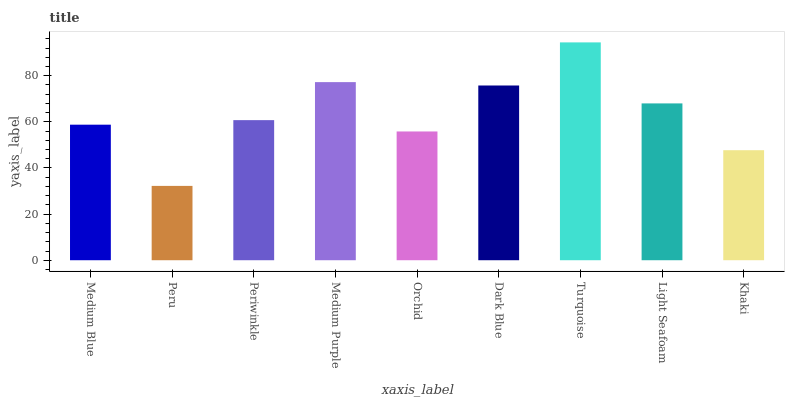Is Periwinkle the minimum?
Answer yes or no. No. Is Periwinkle the maximum?
Answer yes or no. No. Is Periwinkle greater than Peru?
Answer yes or no. Yes. Is Peru less than Periwinkle?
Answer yes or no. Yes. Is Peru greater than Periwinkle?
Answer yes or no. No. Is Periwinkle less than Peru?
Answer yes or no. No. Is Periwinkle the high median?
Answer yes or no. Yes. Is Periwinkle the low median?
Answer yes or no. Yes. Is Medium Purple the high median?
Answer yes or no. No. Is Peru the low median?
Answer yes or no. No. 